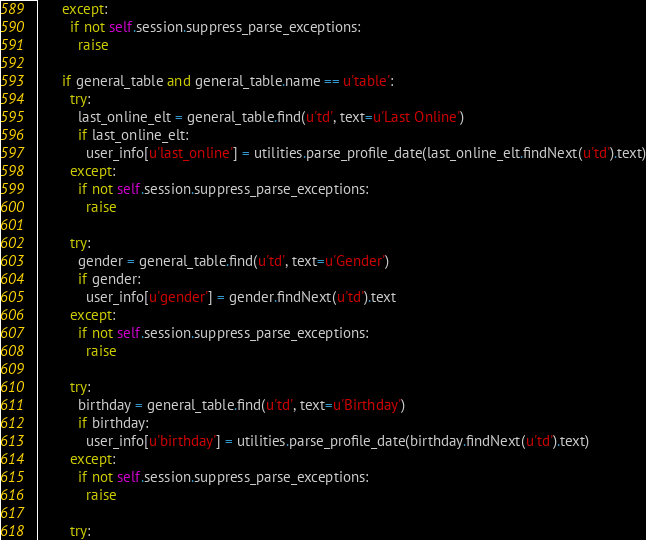Convert code to text. <code><loc_0><loc_0><loc_500><loc_500><_Python_>      except:
        if not self.session.suppress_parse_exceptions:
          raise

      if general_table and general_table.name == u'table':
        try:
          last_online_elt = general_table.find(u'td', text=u'Last Online')
          if last_online_elt:
            user_info[u'last_online'] = utilities.parse_profile_date(last_online_elt.findNext(u'td').text)
        except:
          if not self.session.suppress_parse_exceptions:
            raise

        try:
          gender = general_table.find(u'td', text=u'Gender')
          if gender:
            user_info[u'gender'] = gender.findNext(u'td').text
        except:
          if not self.session.suppress_parse_exceptions:
            raise

        try:
          birthday = general_table.find(u'td', text=u'Birthday')
          if birthday:
            user_info[u'birthday'] = utilities.parse_profile_date(birthday.findNext(u'td').text)
        except:
          if not self.session.suppress_parse_exceptions:
            raise

        try:</code> 